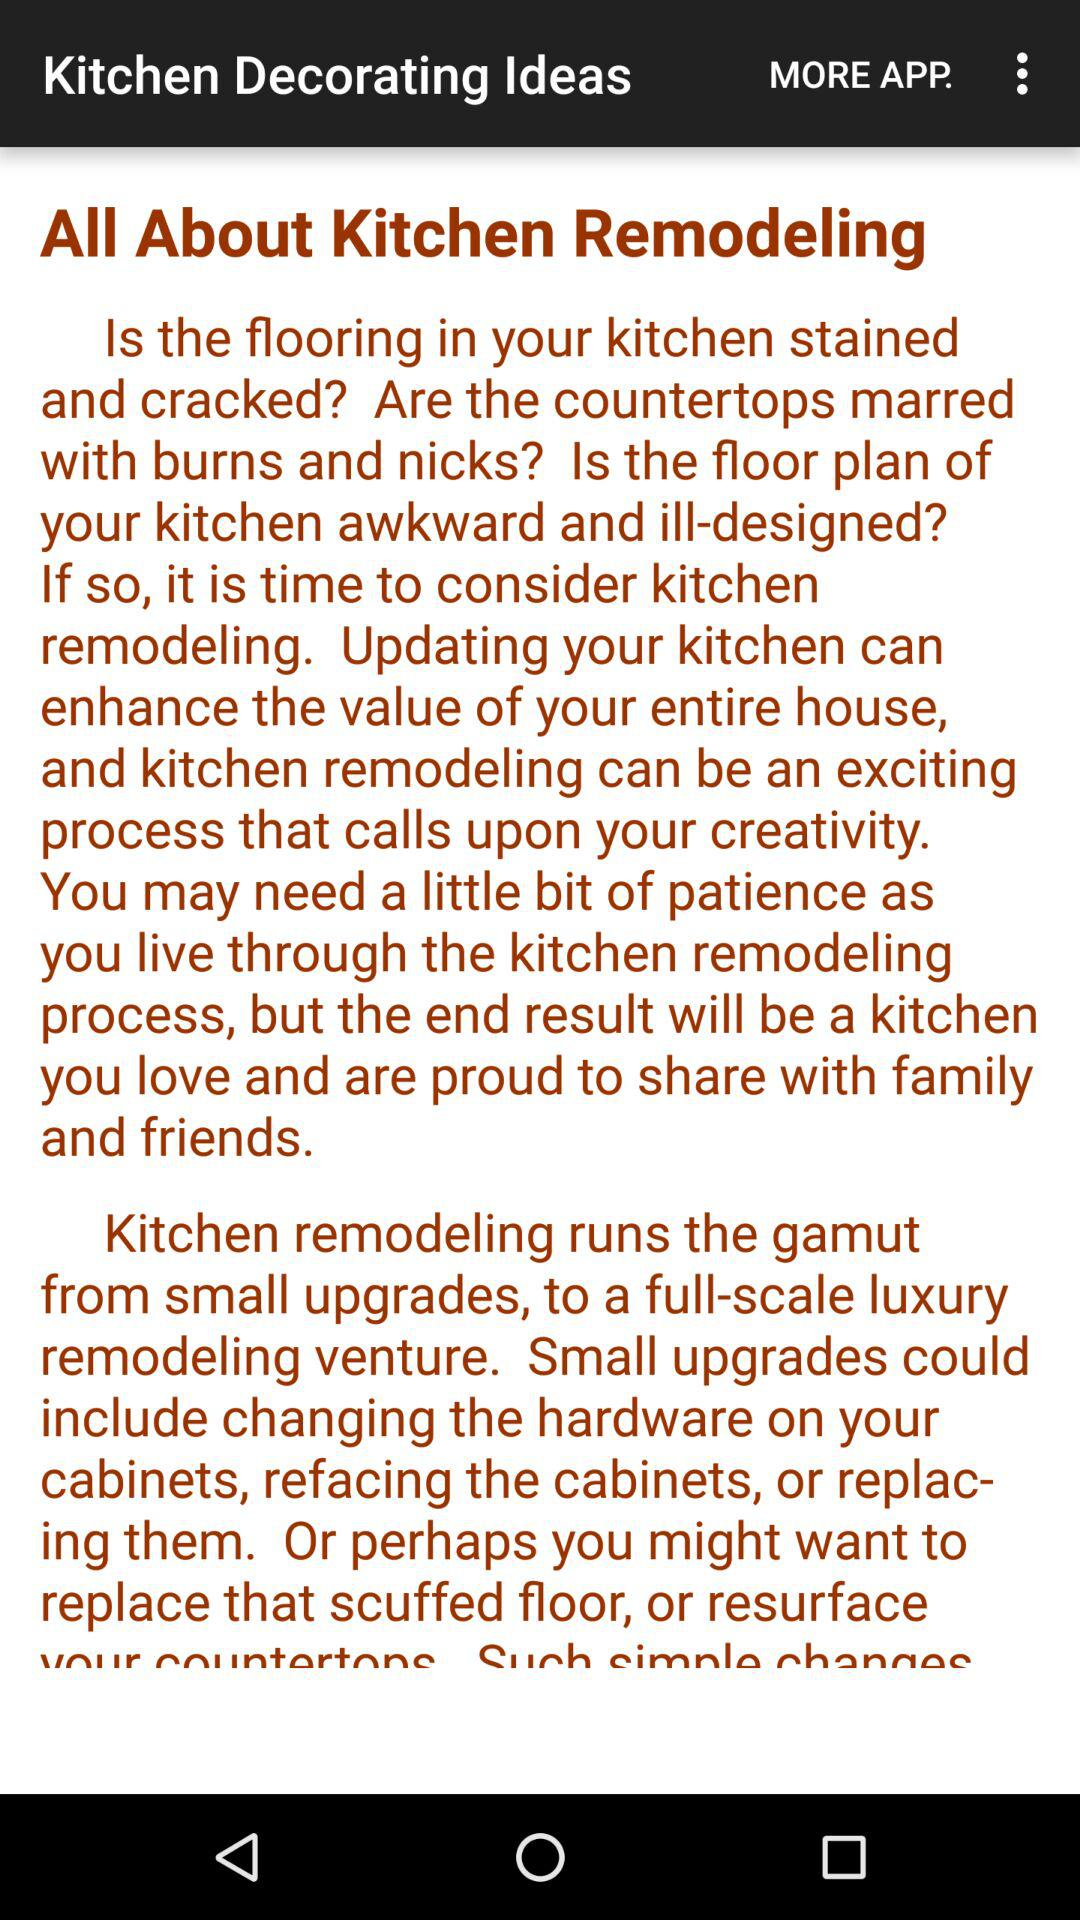What is the app name? The app name is "Kitchen Decorating Ideas". 